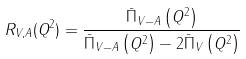<formula> <loc_0><loc_0><loc_500><loc_500>R _ { V , A } ( Q ^ { 2 } ) = \frac { \bar { \Pi } _ { V - A } \left ( Q ^ { 2 } \right ) } { \bar { \Pi } _ { V - A } \left ( Q ^ { 2 } \right ) - 2 \bar { \Pi } _ { V } \left ( Q ^ { 2 } \right ) }</formula> 